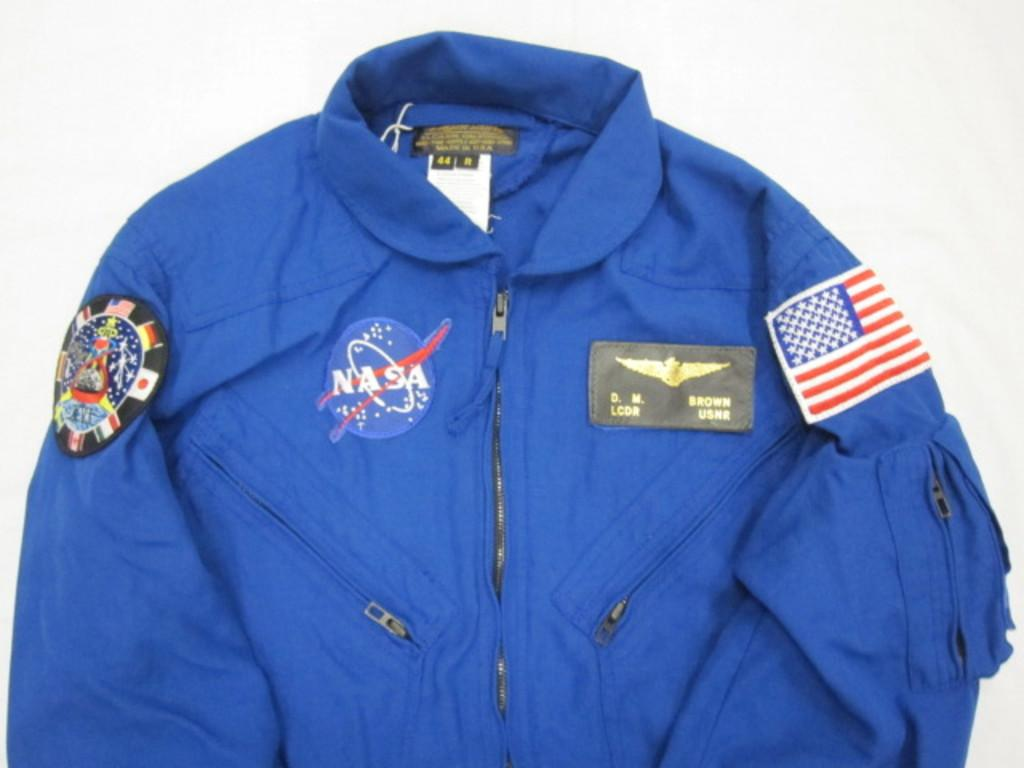<image>
Summarize the visual content of the image. a jacket with the word NASA on the front 